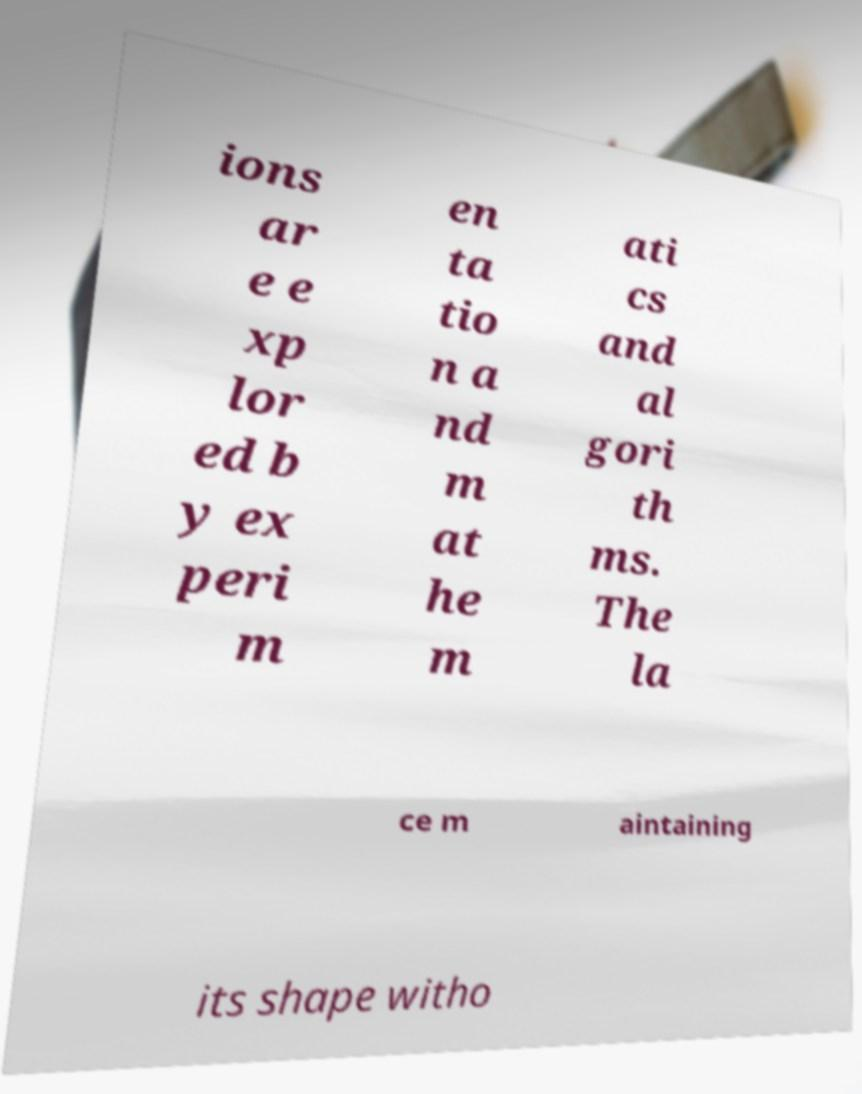What messages or text are displayed in this image? I need them in a readable, typed format. ions ar e e xp lor ed b y ex peri m en ta tio n a nd m at he m ati cs and al gori th ms. The la ce m aintaining its shape witho 